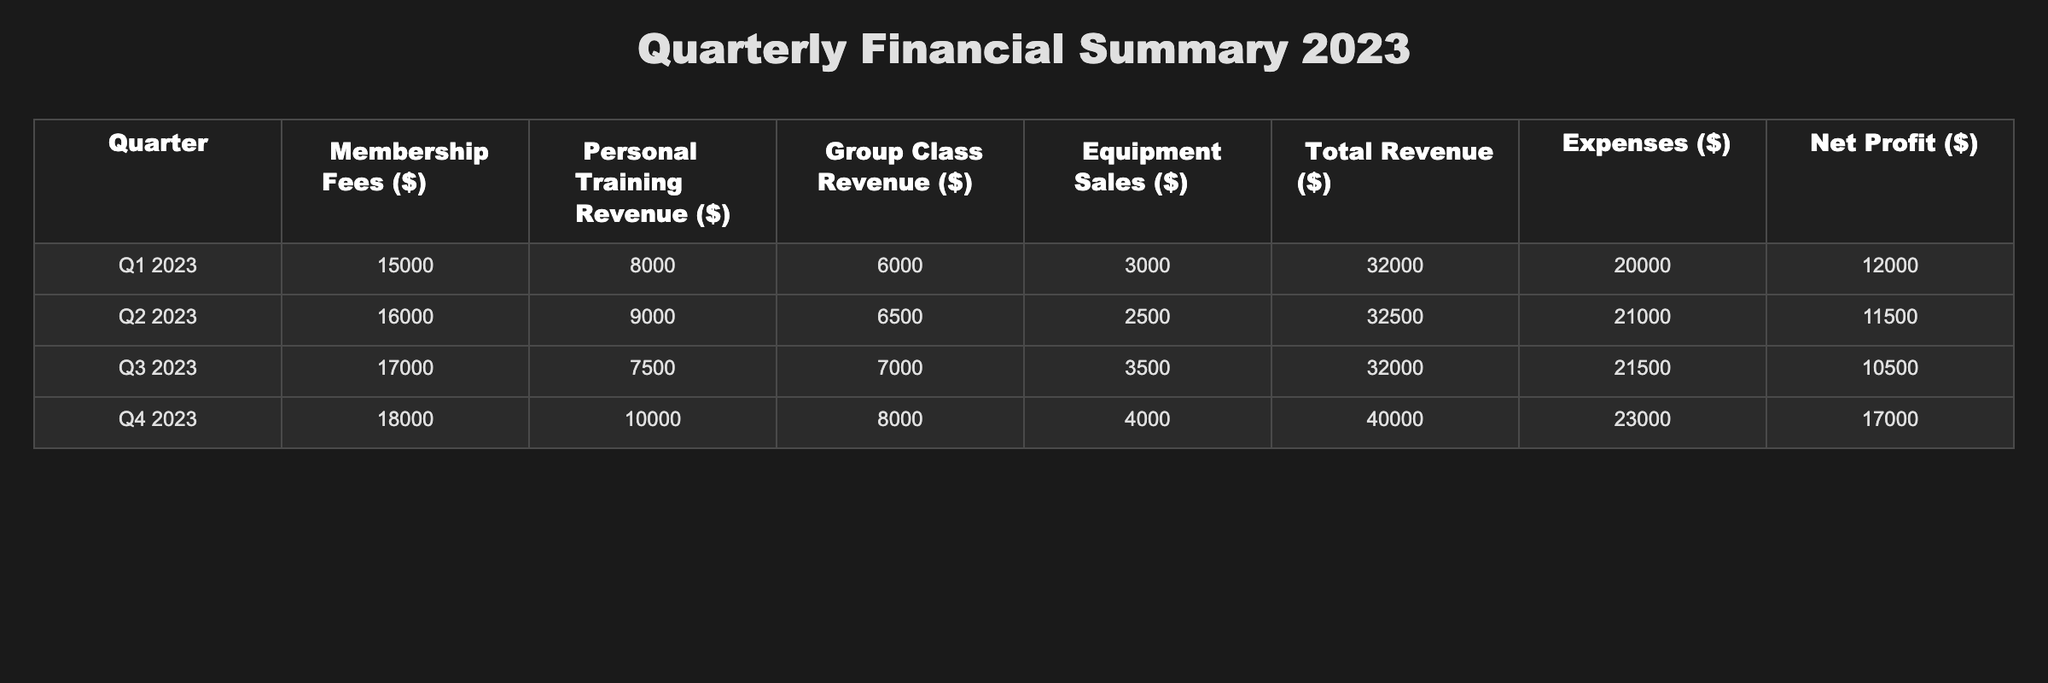What was the total revenue in Q4 2023? The table shows that the total revenue for Q4 2023 is $40,000.
Answer: $40,000 What are the membership fees for Q1 2023? According to the table, the membership fees for Q1 2023 are $15,000.
Answer: $15,000 Which quarter had the highest personal training revenue? By comparing the personal training revenue across quarters, Q4 2023 has the highest at $10,000.
Answer: Q4 2023 What is the net profit for Q2 2023? The net profit for Q2 2023, as listed in the table, is $11,500.
Answer: $11,500 How much did group class revenue increase from Q1 to Q4 2023? The group class revenue was $6,000 in Q1 and $8,000 in Q4; the increase is $8,000 - $6,000 = $2,000.
Answer: $2,000 What were the total expenses for the gym in 2023? To find the total expenses for the year, we add the expenses from each quarter: $20,000 + $21,000 + $21,500 + $23,000 = $85,500.
Answer: $85,500 Did the gym’s net profit increase from Q3 to Q4 2023? Yes, the net profit in Q3 2023 was $10,500 and in Q4 2023 it increased to $17,000.
Answer: Yes What is the average membership fee over the four quarters in 2023? The average is calculated by adding all membership fees: ($15,000 + $16,000 + $17,000 + $18,000) / 4 = $16,500.
Answer: $16,500 Which quarter had the lowest total revenue? By comparing total revenues, Q3 2023 had the lowest total revenue at $32,000.
Answer: Q3 2023 How much did equipment sales vary from Q2 to Q4 2023? Equipment sales were $2,500 in Q2 and increased to $4,000 in Q4; the variance is $4,000 - $2,500 = $1,500.
Answer: $1,500 What was the overall net profit for the gym in 2023? The overall net profit is calculated by summing the net profits from all quarters: $12,000 + $11,500 + $10,500 + $17,000 = $51,000.
Answer: $51,000 